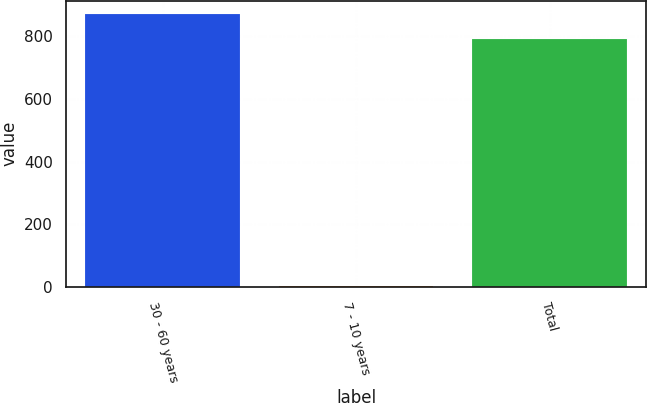Convert chart. <chart><loc_0><loc_0><loc_500><loc_500><bar_chart><fcel>30 - 60 years<fcel>7 - 10 years<fcel>Total<nl><fcel>871.2<fcel>4<fcel>792<nl></chart> 